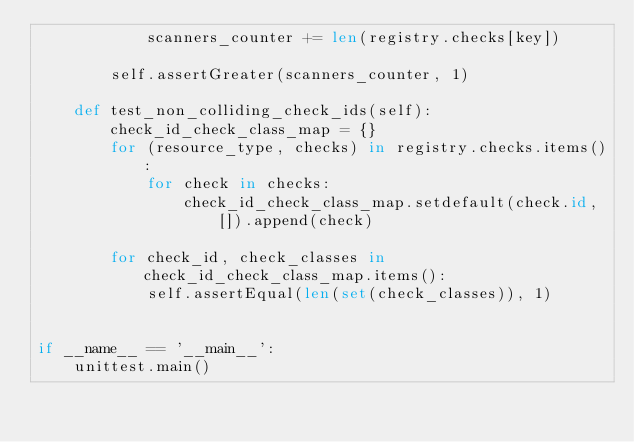<code> <loc_0><loc_0><loc_500><loc_500><_Python_>            scanners_counter += len(registry.checks[key])

        self.assertGreater(scanners_counter, 1)

    def test_non_colliding_check_ids(self):
        check_id_check_class_map = {}
        for (resource_type, checks) in registry.checks.items():
            for check in checks:
                check_id_check_class_map.setdefault(check.id, []).append(check)

        for check_id, check_classes in check_id_check_class_map.items():
            self.assertEqual(len(set(check_classes)), 1)


if __name__ == '__main__':
    unittest.main()
</code> 